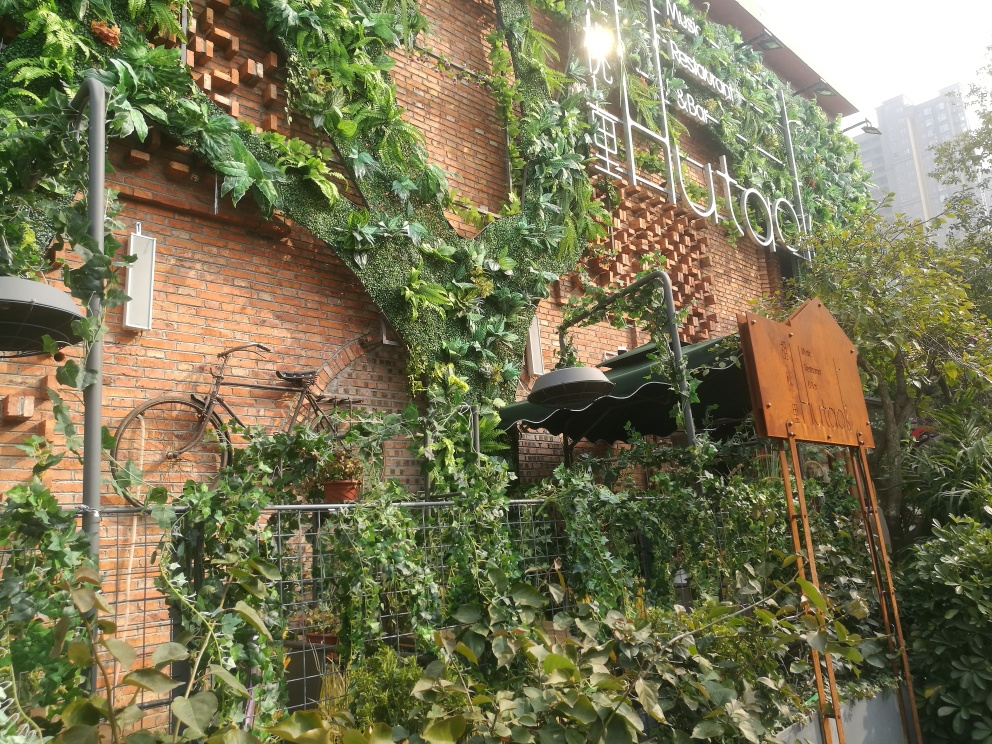What's the significance of the bicycle on the wall? The vintage bicycle mounted on the wall above the green ivy serves as a unique decorative element, possibly reflecting an eco-friendly or cycling-friendly ethos of the establishment. 